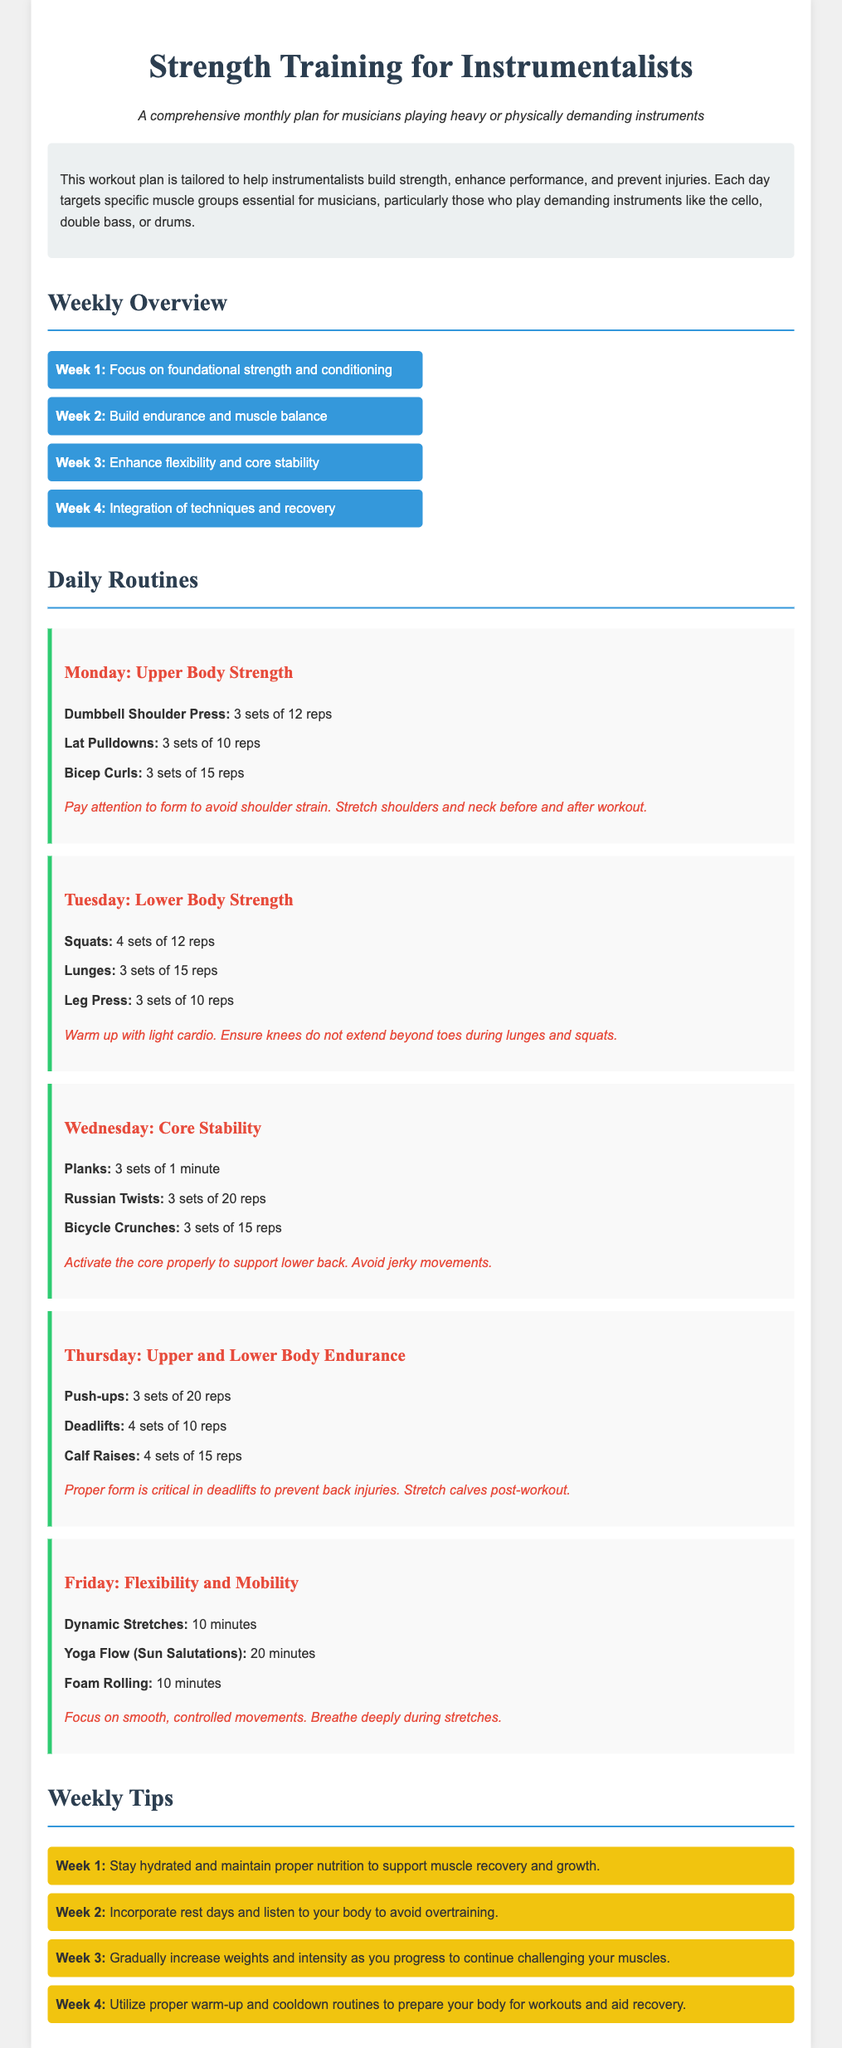What is the title of the document? The title of the document is prominently displayed at the top and is "Strength Training for Instrumentalists".
Answer: Strength Training for Instrumentalists How many sets are recommended for Dumbbell Shoulder Press? The document specifies the number of sets for each exercise under the daily routines, which is 3 sets for Dumbbell Shoulder Press.
Answer: 3 sets Which week focuses on flexibility and core stability? The document outlines the focus of each week, with Week 3 dedicated to enhancing flexibility and core stability.
Answer: Week 3 What exercise requires 4 sets of 10 reps? The exercises listed under "Thursday: Upper and Lower Body Endurance" state that Deadlifts require 4 sets of 10 reps.
Answer: Deadlifts What should be done for injury prevention after Deadlifts? The document mentions injury prevention tips, stating that calves should be stretched after the workout.
Answer: Stretch calves What is one of the weekly tips for Week 2? Each week has a specific tip, and for Week 2, it advises incorporating rest days to avoid overtraining.
Answer: Incorporate rest days What muscle groups does the plan aim to strengthen? The document specifically mentions focusing on muscle groups essential for musicians, particularly for those who play demanding instruments.
Answer: Essential muscle groups for musicians What type of stretches are recommended for Friday? The Friday routine indicates that Dynamic Stretches are recommended for 10 minutes as part of the flexibility and mobility focus.
Answer: Dynamic Stretches 